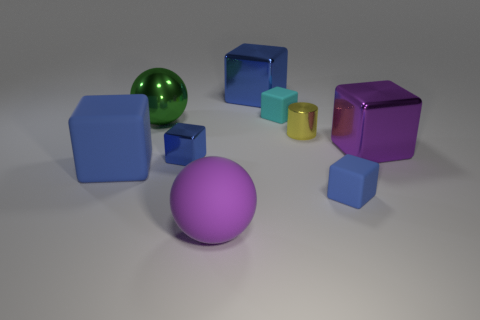Subtract all brown cylinders. How many blue cubes are left? 4 Subtract all small shiny blocks. How many blocks are left? 5 Subtract all cyan blocks. How many blocks are left? 5 Add 1 large rubber balls. How many objects exist? 10 Subtract 2 blocks. How many blocks are left? 4 Subtract all spheres. How many objects are left? 7 Add 9 cylinders. How many cylinders are left? 10 Add 6 small yellow metallic cylinders. How many small yellow metallic cylinders exist? 7 Subtract 0 brown blocks. How many objects are left? 9 Subtract all blue balls. Subtract all green blocks. How many balls are left? 2 